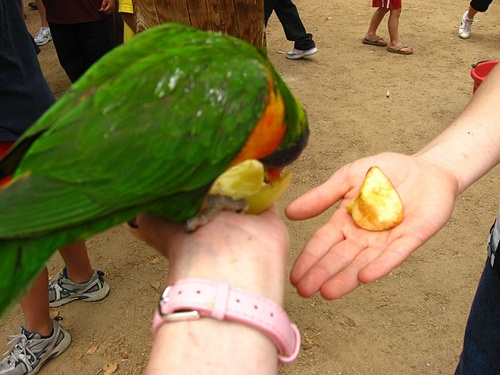Describe the objects in this image and their specific colors. I can see bird in black, darkgreen, and green tones, people in black, tan, beige, and salmon tones, people in black, ivory, tan, and maroon tones, people in black, maroon, and gray tones, and people in black, maroon, and darkgreen tones in this image. 